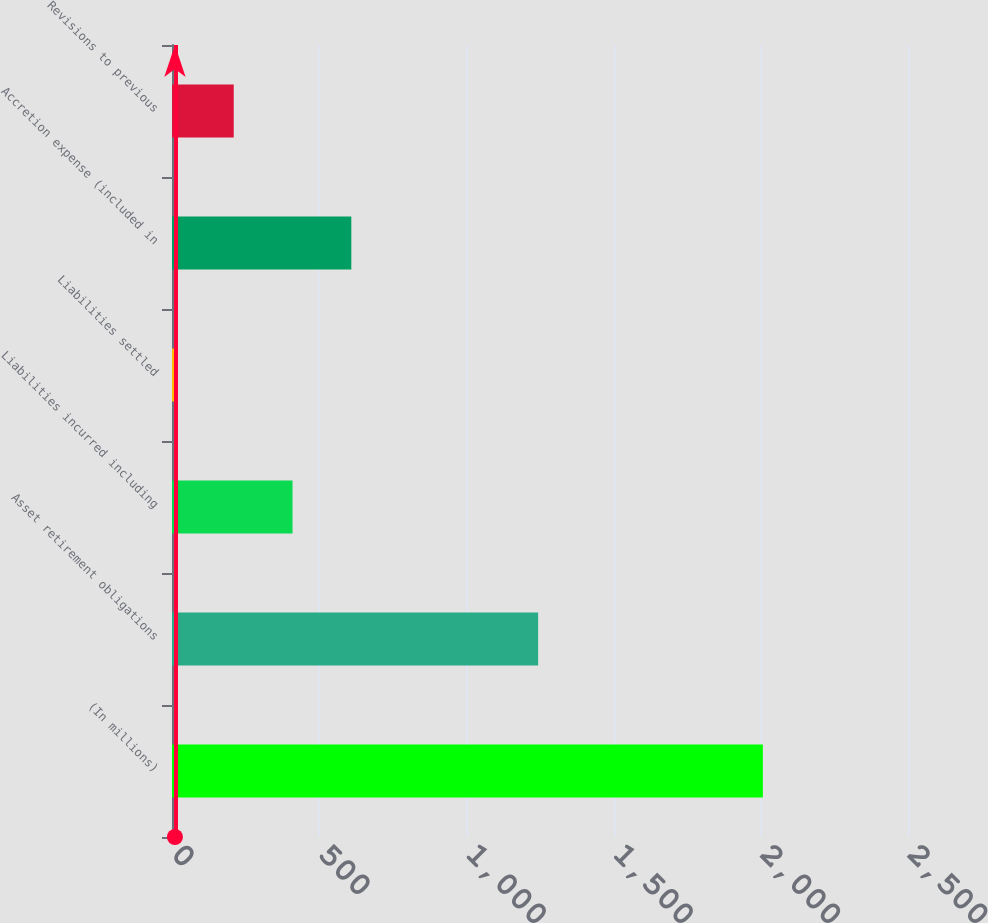Convert chart to OTSL. <chart><loc_0><loc_0><loc_500><loc_500><bar_chart><fcel>(In millions)<fcel>Asset retirement obligations<fcel>Liabilities incurred including<fcel>Liabilities settled<fcel>Accretion expense (included in<fcel>Revisions to previous<nl><fcel>2007<fcel>1243.7<fcel>409.4<fcel>10<fcel>609.1<fcel>209.7<nl></chart> 